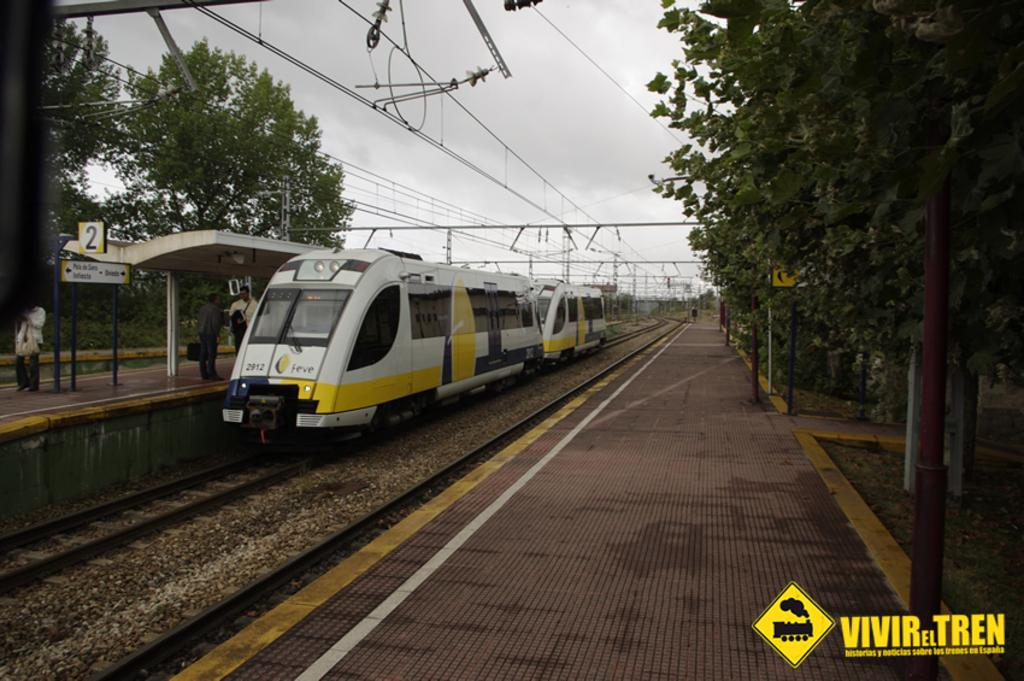Provide a one-sentence caption for the provided image. a train that is neat a vivir tren ad. 